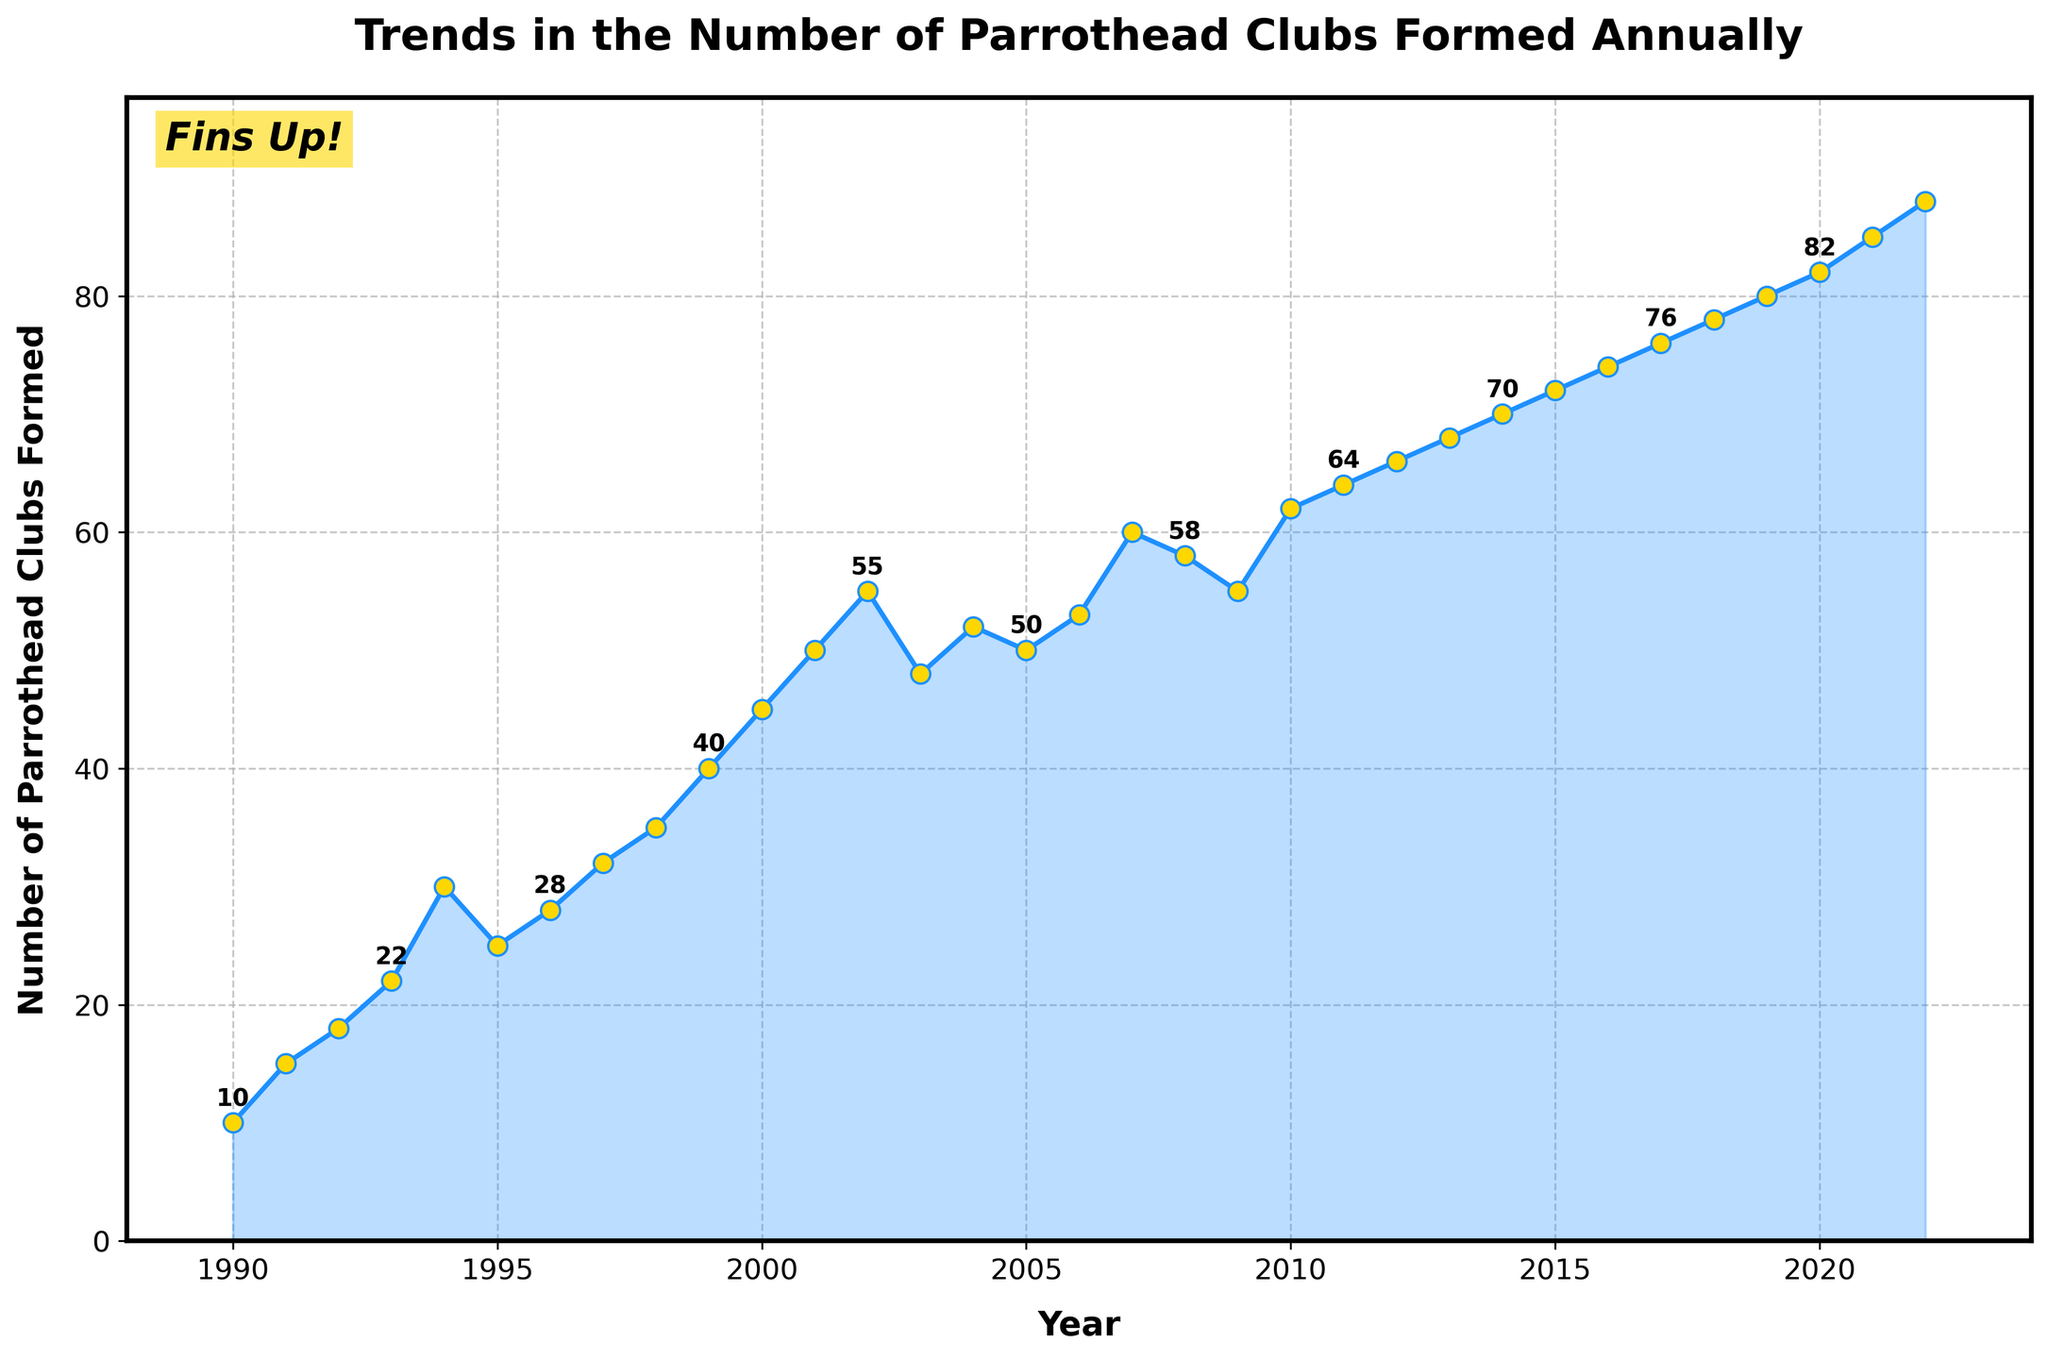What's the title of the plot? The title of the plot is located at the top and it reads, "Trends in the Number of Parrothead Clubs Formed Annually".
Answer: Trends in the Number of Parrothead Clubs Formed Annually What is the x-axis label? The x-axis label is situated below the horizontal axis and indicates the variable being measured on that axis, which is "Year".
Answer: Year What is the highest number of Parrothead clubs formed in a single year? By looking at the y-axis and the data points, the highest number of Parrothead clubs formed in a single year occurs in 2022 and the number is 88.
Answer: 88 How many Parrothead clubs were formed in 2000? Referring to the data point corresponding to the year 2000, the graph shows that 45 Parrothead clubs were formed in that year.
Answer: 45 Between which years did the number of Parrothead clubs show the most significant increase? Observing the plot, the most significant increase appears between 2001 and 2002, where the number of clubs increased from 50 to 55.
Answer: 2001 and 2002 What's the overall trend in the number of Parrothead clubs formed from 1990 to 2022? Analyzing the plot from start (1990) to end (2022), there's a general upward trend observed in the number of Parrothead clubs formed, indicating consistent growth over the years.
Answer: Upward trend How many Parrothead clubs were formed in the years ending with 0 (e.g., 1990, 2000, 2010, 2020)? From the graph, the number of clubs formed in 1990, 2000, 2010, and 2020 are 10, 45, 62, and 82 respectively. Adding these gives 10 + 45 + 62 + 82 = 199.
Answer: 199 Which year experienced a peak formation of Parrothead clubs followed by a decline the next year? By analyzing annual fluctuations, 2002 experienced a peak with 55 clubs, followed by a decline to 48 clubs in 2003.
Answer: 2002 How does the number of clubs formed in 2010 compare to that in 2020? Observing the data points, in 2010, 62 clubs were formed, and in 2020, 82 clubs were formed. Hence, 2020 saw 20 more clubs formed than in 2010.
Answer: 20 more What annotation appears at the top-left corner of the plot? In the upper-left corner of the plot, there's a text annotation saying, "Fins Up!" with a decorative box around it.
Answer: Fins Up! 